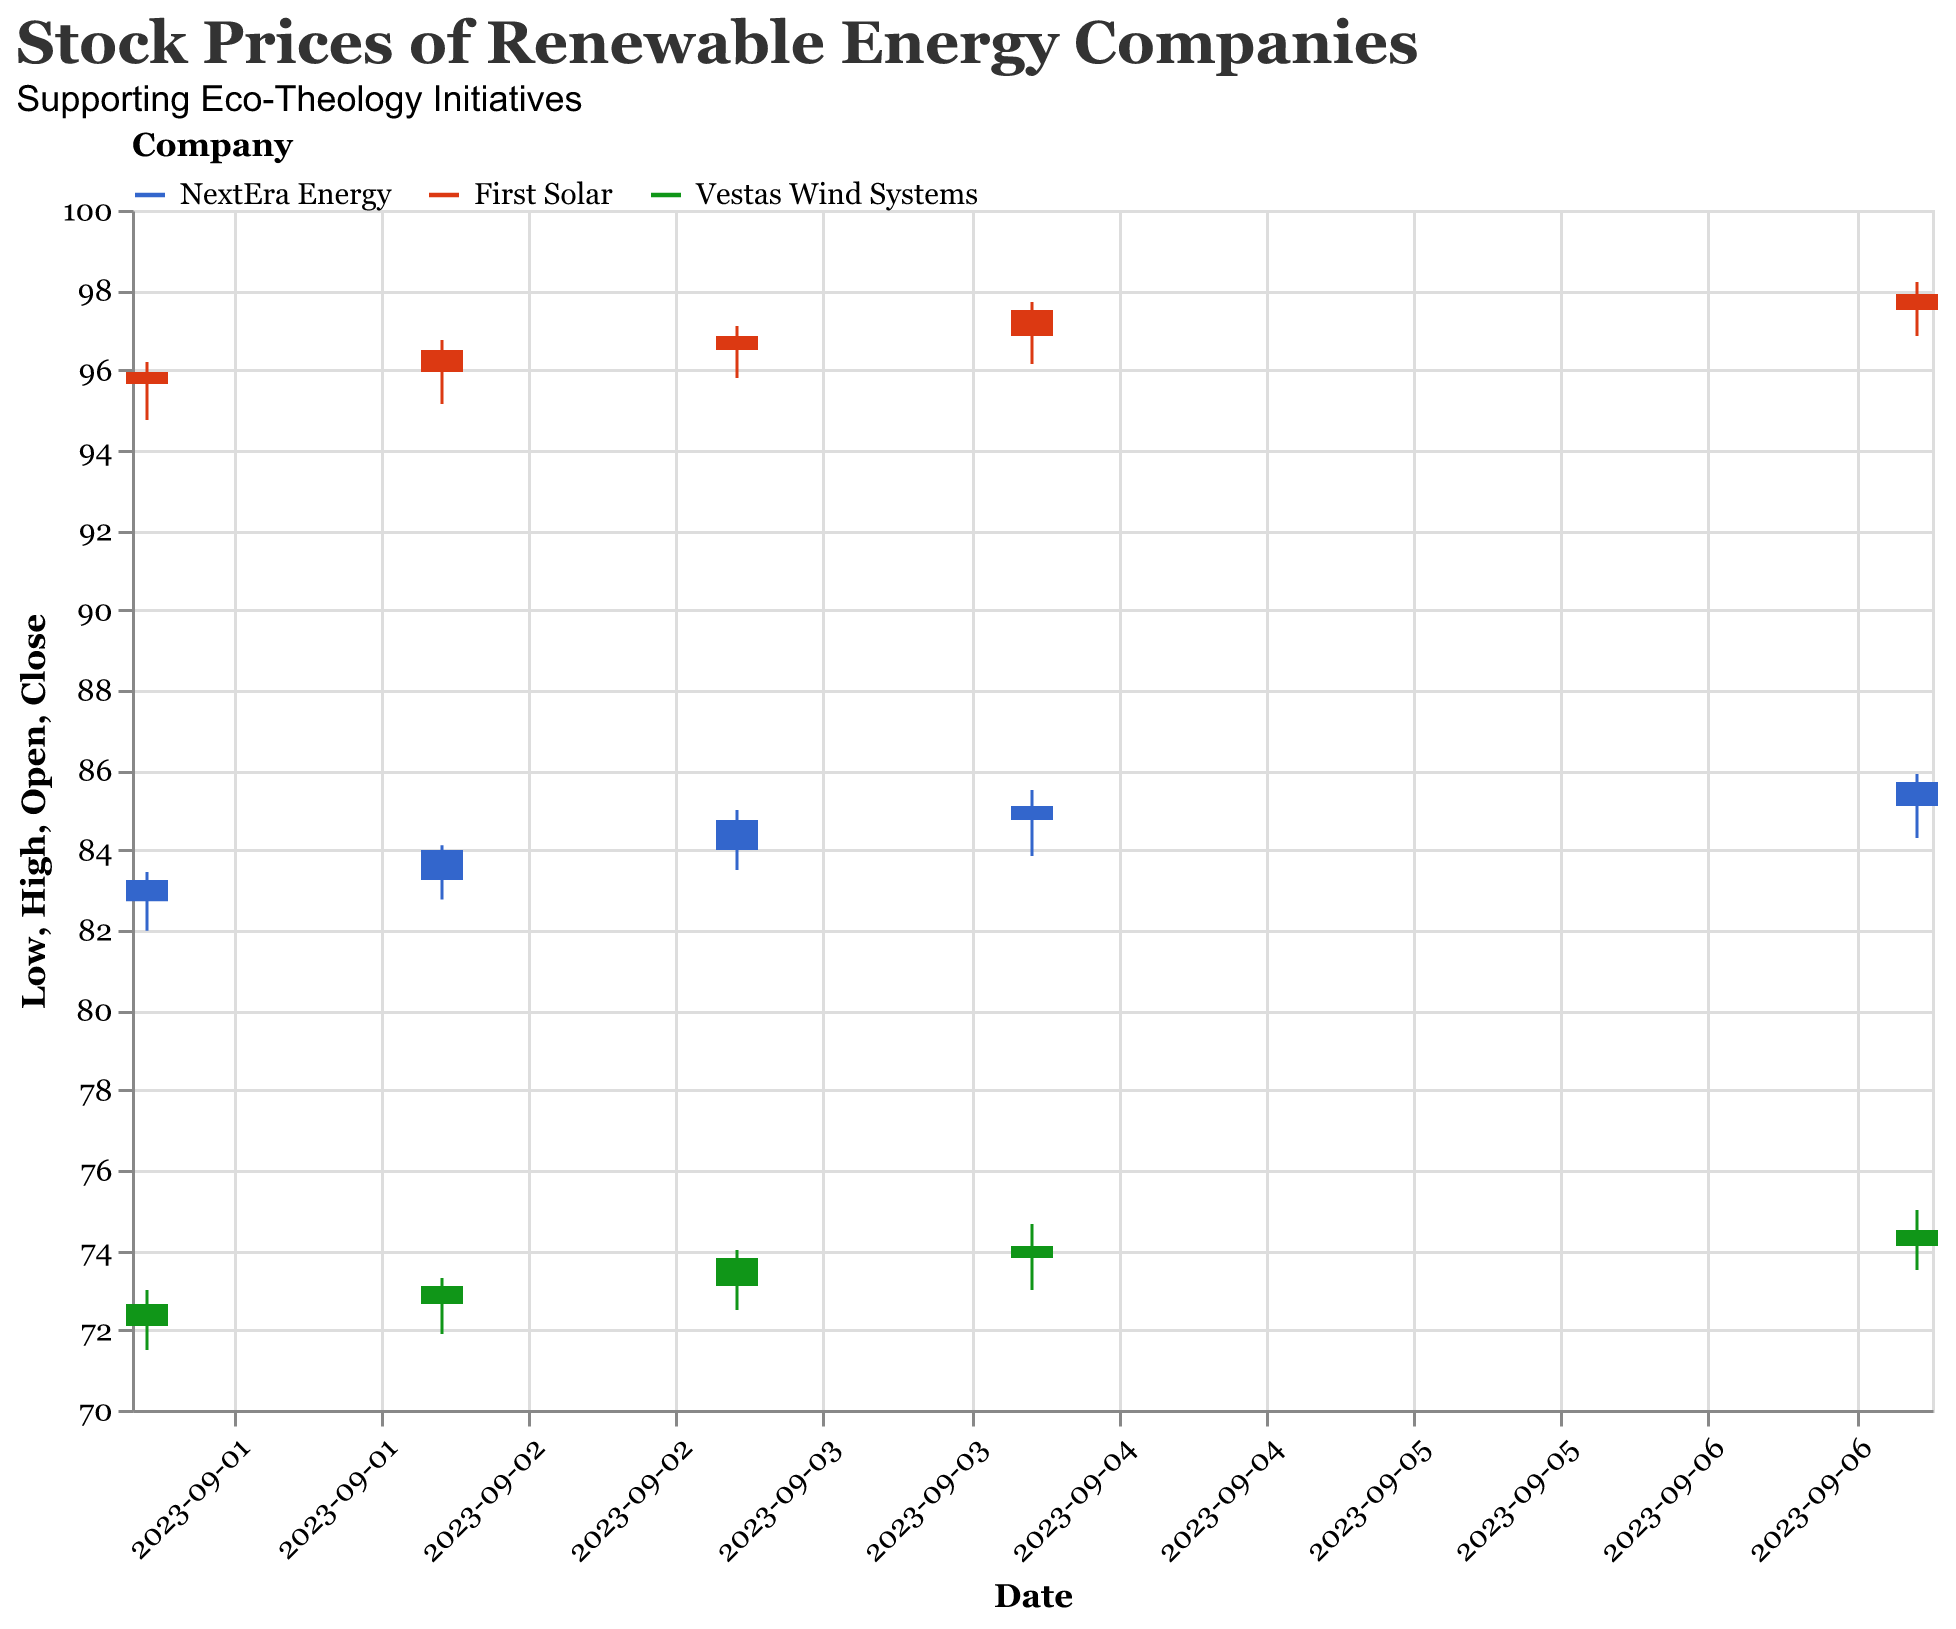What is the title of the figure? The title of the figure is usually located at the top and summarizes the content of the plot. Here the title is provided within the visual configuration.
Answer: Stock Prices of Renewable Energy Companies Which company had the highest closing price on September 7, 2023? To determine this, look at the "Close" prices on September 7, 2023, for all companies and compare them. First Solar had the highest closing price of 97.90.
Answer: First Solar How did the stock price of NextEra Energy change from its opening to its closing on September 3, 2023? The change is calculated by subtracting the opening price from the closing price on that date: 84.75 (Close) - 84.00 (Open) = 0.75.
Answer: Increased by 0.75 Which company showed the smallest fluctuation in stock price on any given day from September 1 to September 7, 2023? This requires comparing the ranges (High - Low) for each company on each date. The smallest fluctuation is found by comparing all ranges. On September 4, 2023, Vestas Wind Systems had the smallest fluctuation: 74.65 - 73.00 = 1.65.
Answer: Vestas Wind Systems (1.65 on September 4) What is the average closing price of First Solar over the recorded dates? Sum the closing prices for First Solar (95.95, 96.50, 96.85, 97.50, 97.90) and divide by the number of entries: (95.95 + 96.50 + 96.85 + 97.50 + 97.90) / 5 = 96.94.
Answer: 96.94 On which date did Vestas Wind Systems have the highest closing price? Check all closing prices for Vestas Wind Systems and identify the date with the highest value. The highest closing price is on September 7, with a closing price of 74.50.
Answer: September 7, 2023 Compare the overall trend in closing prices for NextEra Energy and First Solar. Which one had a more consistent increase? Observe the closing prices trends for NextEra Energy (83.25, 84.00, 84.75, 85.10, 85.70) and First Solar (95.95, 96.50, 96.85, 97.50, 97.90). NextEra Energy shows a more linear and consistent upward trend.
Answer: NextEra Energy What is the total trading volume for Vestas Wind Systems over the five recorded dates? Sum the trading volumes for Vestas Wind Systems: 2600000 + 2550000 + 2450000 + 2500000 + 2400000 = 12500000.
Answer: 12500000 Which day had the highest trading volume for NextEra Energy? Compare the volumes for all dates and identify the highest one. For NextEra Energy, it was 3400000 on September 1.
Answer: September 1, 2023 